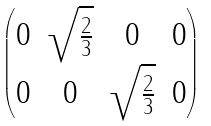<formula> <loc_0><loc_0><loc_500><loc_500>\begin{pmatrix} 0 & \sqrt { \frac { 2 } { 3 } } & 0 & 0 \\ 0 & 0 & \sqrt { \frac { 2 } { 3 } } & 0 \end{pmatrix}</formula> 